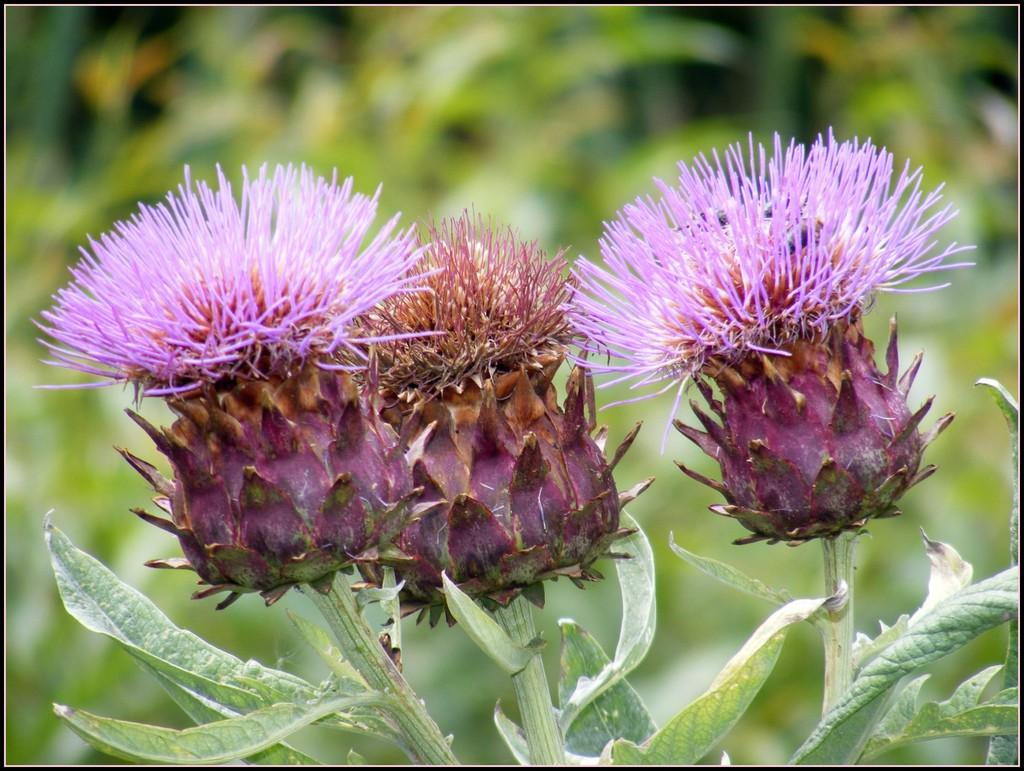What type of living organisms are present in the image? There are plants in the image. What specific features can be observed on the plants? The plants have flowers and leaves. Can you describe the background of the image? The background of the image is blurred. How many needles are sticking out of the flowers in the image? There are no needles present in the image; the plants have flowers and leaves. What type of self-care activity is being performed in the image? There is no self-care activity depicted in the image; it features plants with flowers and leaves. 